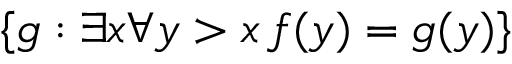Convert formula to latex. <formula><loc_0><loc_0><loc_500><loc_500>\{ g \colon \exists x \forall y > x \, f ( y ) = g ( y ) \}</formula> 